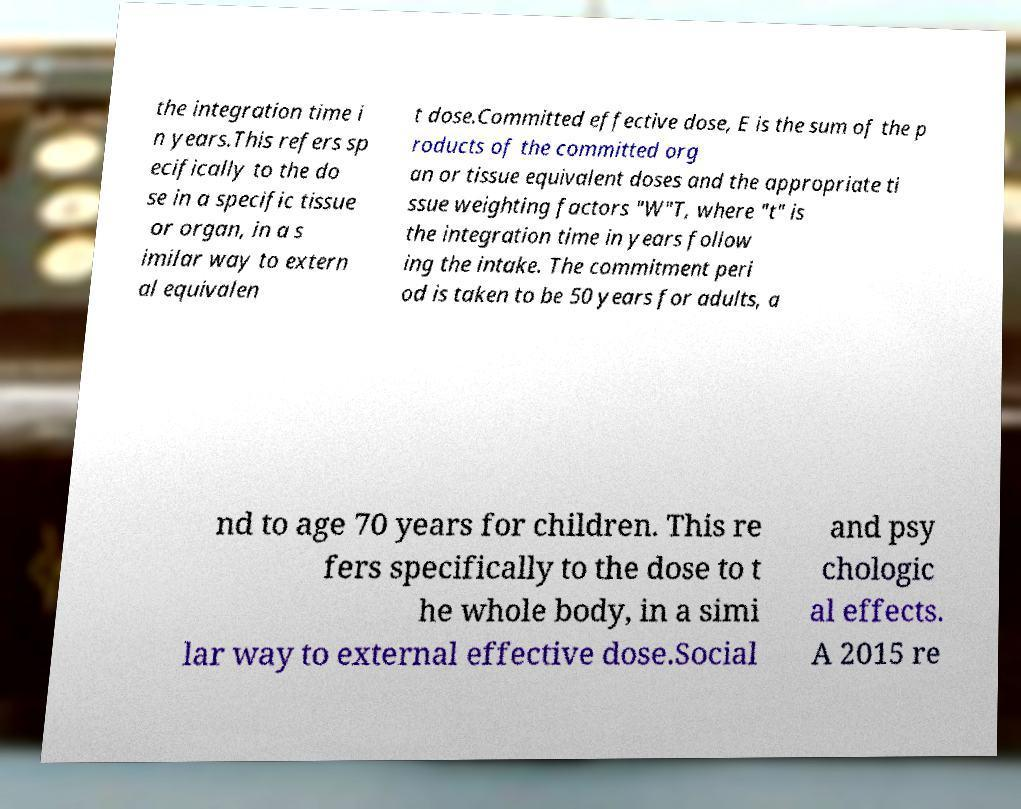What messages or text are displayed in this image? I need them in a readable, typed format. the integration time i n years.This refers sp ecifically to the do se in a specific tissue or organ, in a s imilar way to extern al equivalen t dose.Committed effective dose, E is the sum of the p roducts of the committed org an or tissue equivalent doses and the appropriate ti ssue weighting factors "W"T, where "t" is the integration time in years follow ing the intake. The commitment peri od is taken to be 50 years for adults, a nd to age 70 years for children. This re fers specifically to the dose to t he whole body, in a simi lar way to external effective dose.Social and psy chologic al effects. A 2015 re 